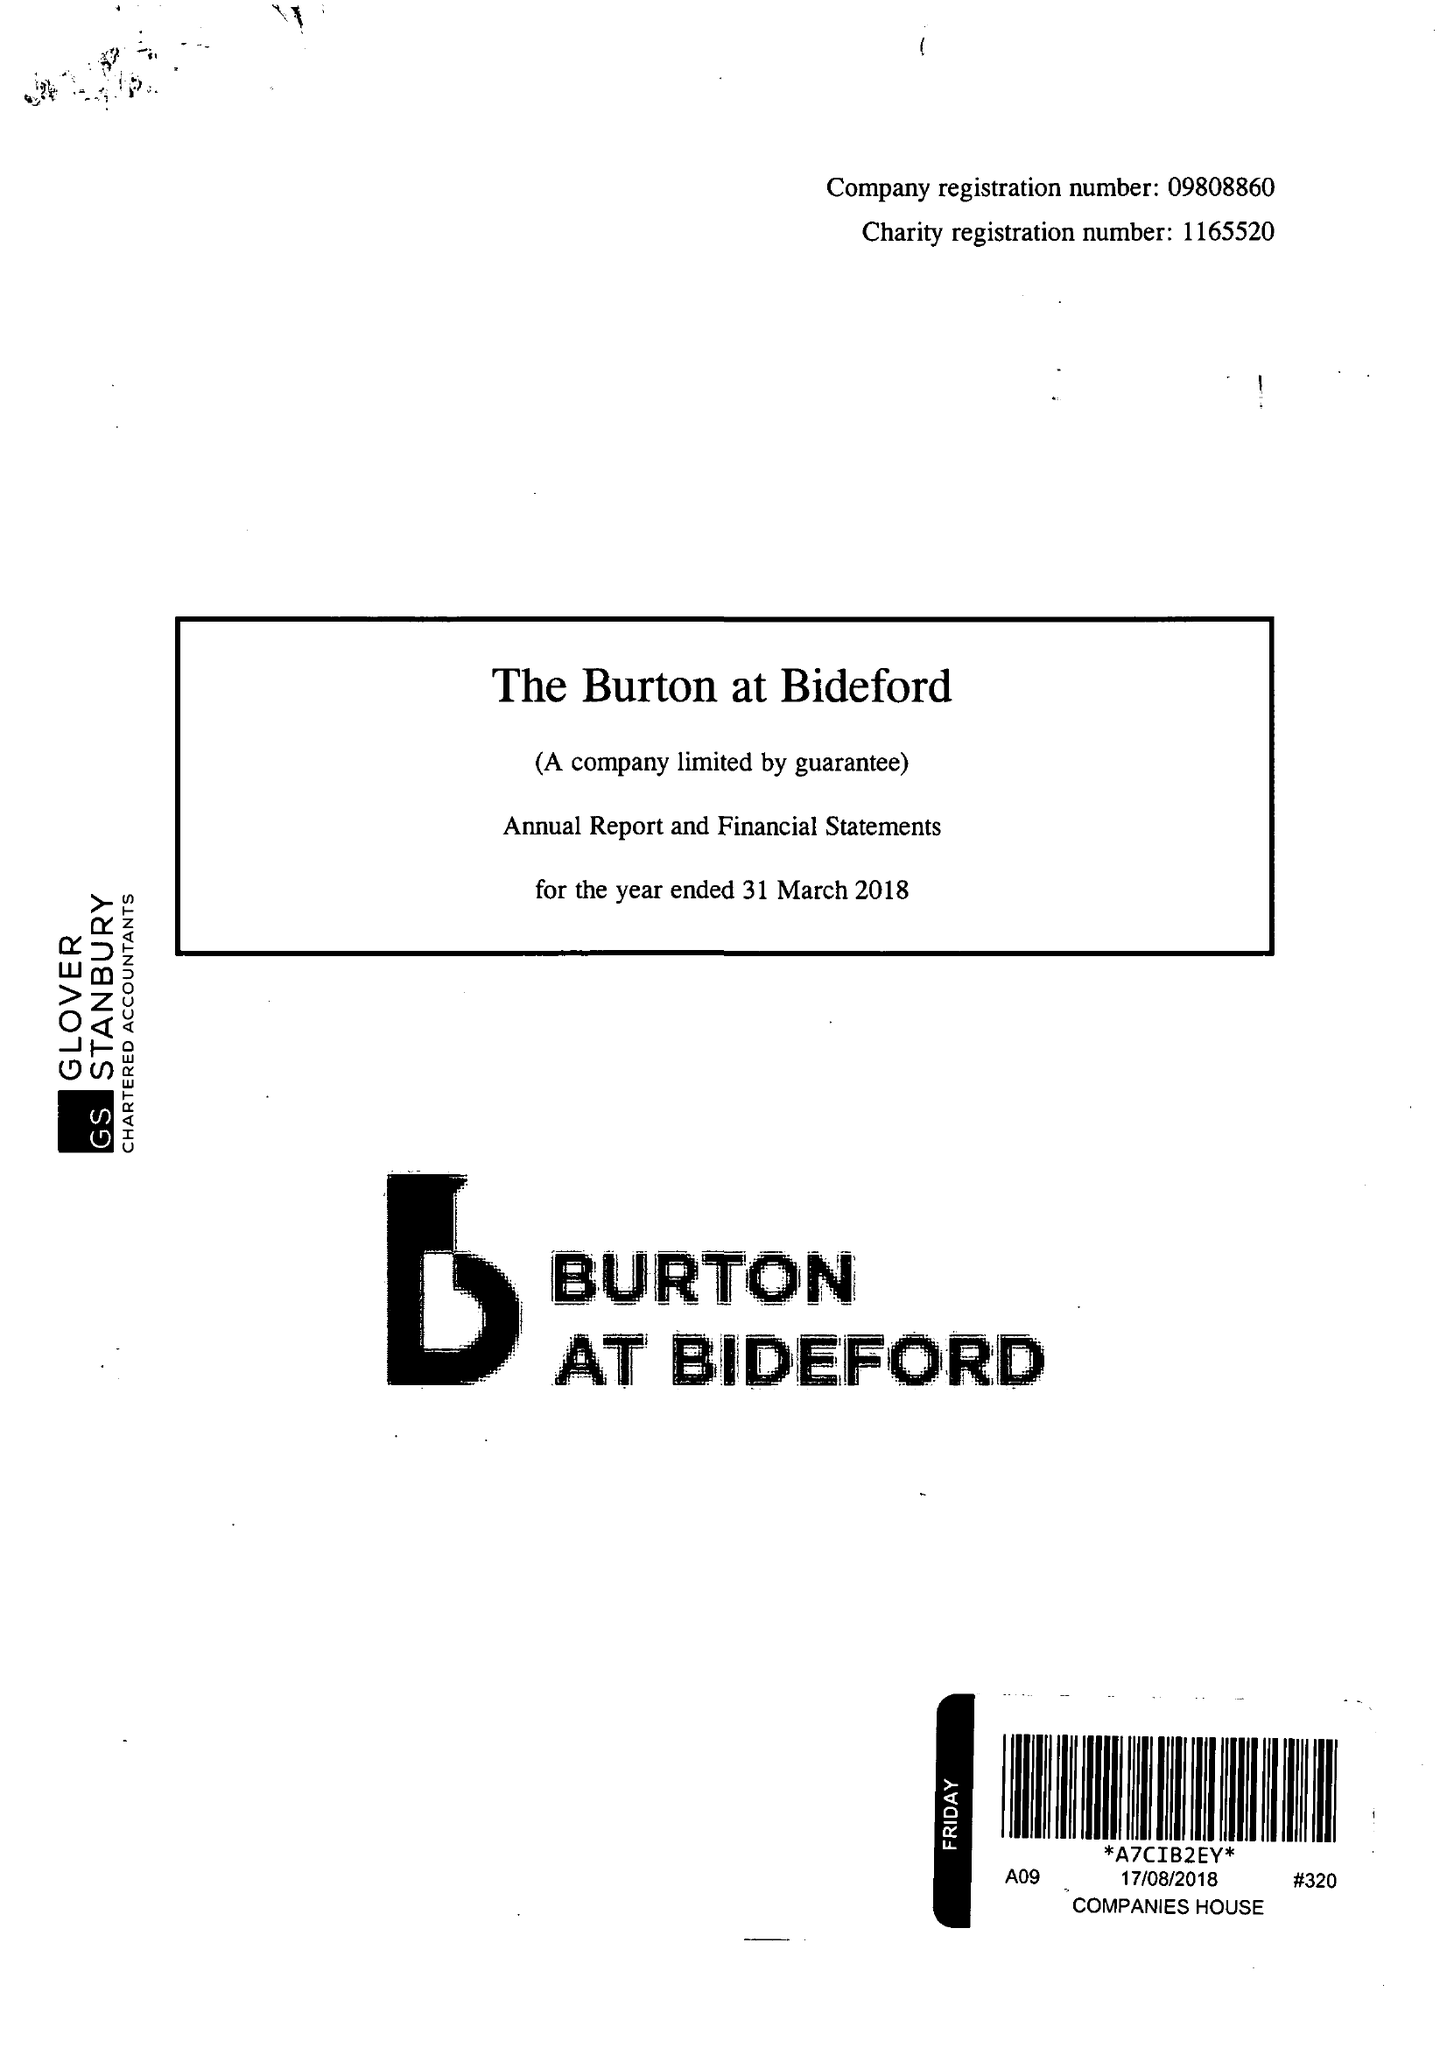What is the value for the report_date?
Answer the question using a single word or phrase. 2018-03-31 